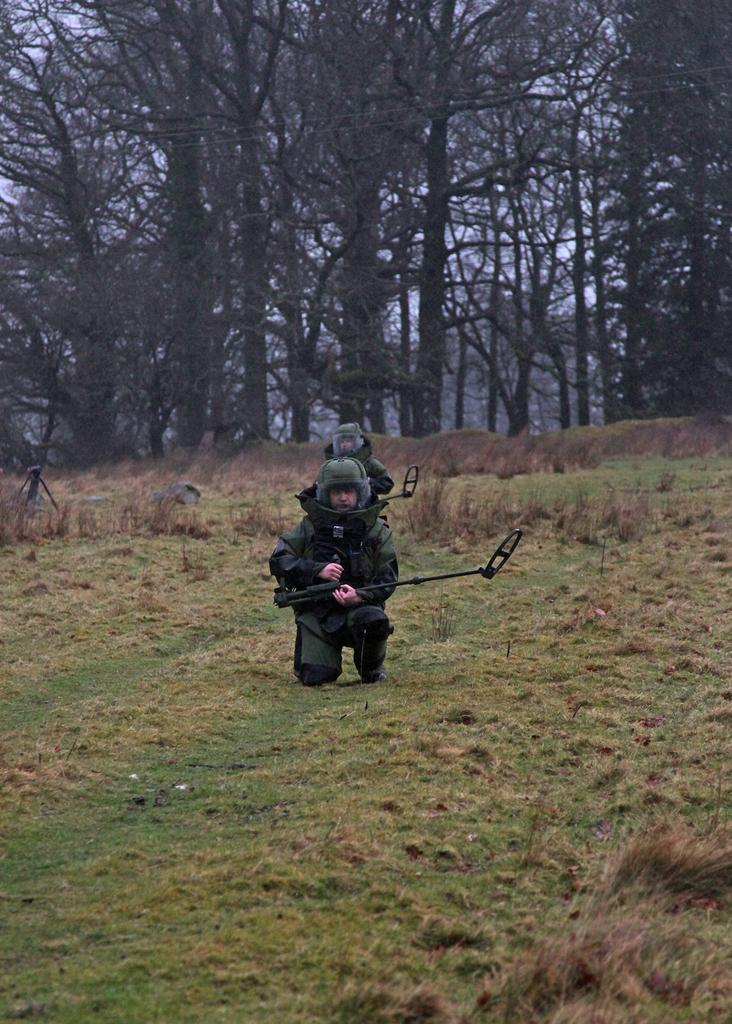How many people are in the image? There are two people in the image. What are the people doing in the image? The people are on the ground and holding sticks. What are the people wearing in the image? The people are wearing uniforms. What can be seen in the background of the image? There are many trees and the sky visible in the background of the image. What type of gun is being used by the people in the image? There are no guns present in the image; the people are holding sticks. What type of fuel is being used by the people in the image? There is no mention of fuel in the image; the people are simply holding sticks. 